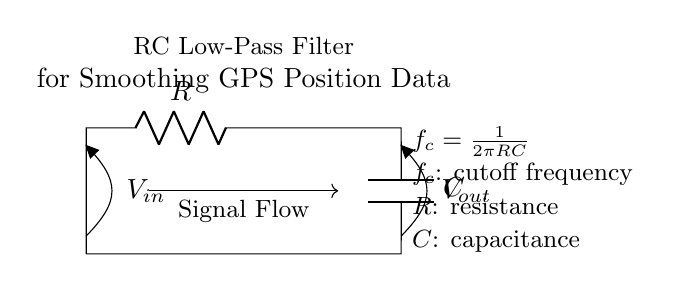What components are in this circuit? The circuit diagram shows a resistor, a capacitor, and an inductor, represented by their symbols. These are the primary components in the circuit.
Answer: resistor, capacitor What is the purpose of this circuit? The circuit is designed as an RC low-pass filter to smooth GPS position data by allowing low-frequency signals to pass while attenuating high-frequency noise.
Answer: smoothing GPS position data What is the cutoff frequency formula? The cutoff frequency, denoted as f_c, is given by the formula f_c = 1/(2πRC). This indicates how the resistor and capacitor values determine the frequency at which the filter transitions from passing to attenuating signals.
Answer: f_c = 1/(2πRC) What happens to high-frequency signals in this circuit? High-frequency signals are attenuated more than low-frequency signals, which allows the filter to effectively smooth out the noise in the GPS position data.
Answer: attenuated How does resistance affect the cutoff frequency? Increasing the resistance R will decrease the cutoff frequency f_c, meaning the filter will allow lower frequencies to pass through and attenuate higher frequencies more. This can be calculated using the cutoff frequency formula.
Answer: decrease cutoff frequency What is the relationship between R and C for smoothing performance? The values of R and C must be appropriately chosen to create a desirable cutoff frequency that effectively smooths the GPS data, balancing response time and noise reduction. A larger product RC results in a lower cutoff frequency.
Answer: R and C must balance for cutoff frequency 